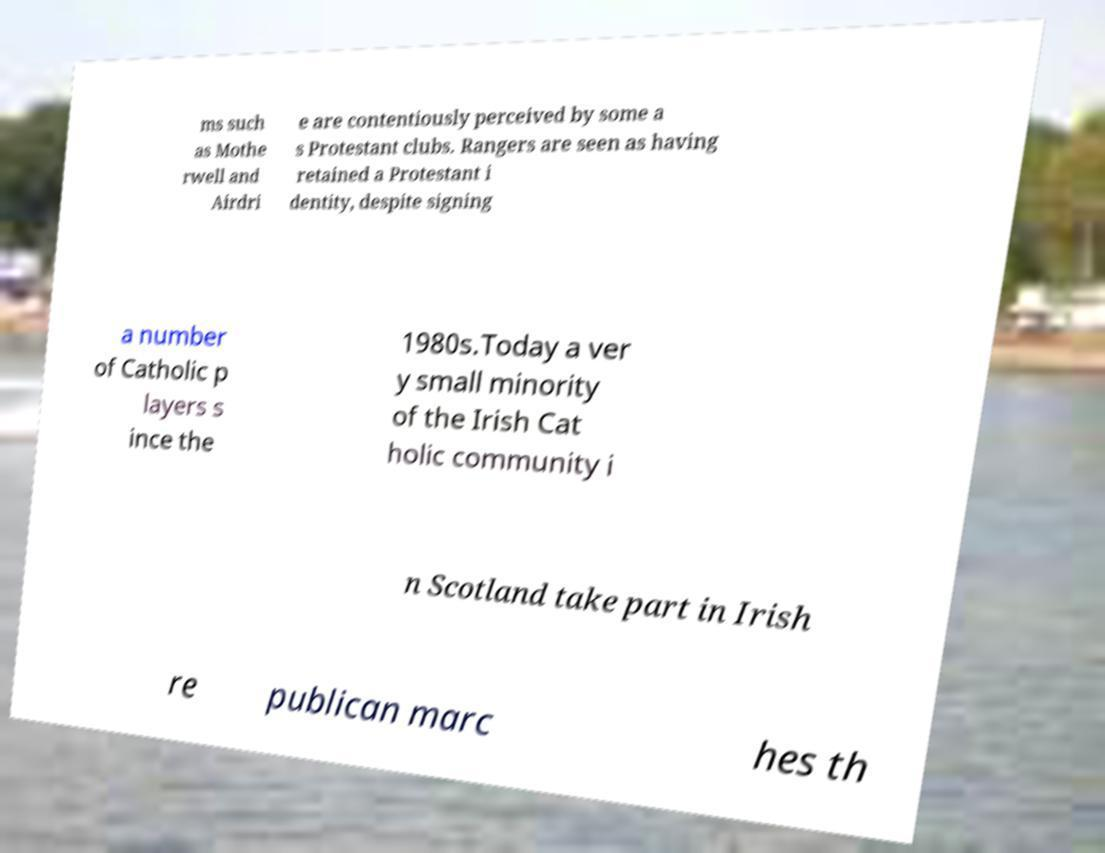Please identify and transcribe the text found in this image. ms such as Mothe rwell and Airdri e are contentiously perceived by some a s Protestant clubs. Rangers are seen as having retained a Protestant i dentity, despite signing a number of Catholic p layers s ince the 1980s.Today a ver y small minority of the Irish Cat holic community i n Scotland take part in Irish re publican marc hes th 